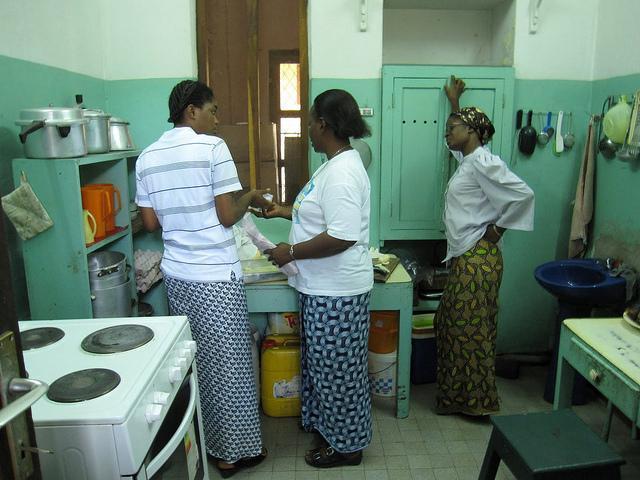How many people are there?
Give a very brief answer. 3. 